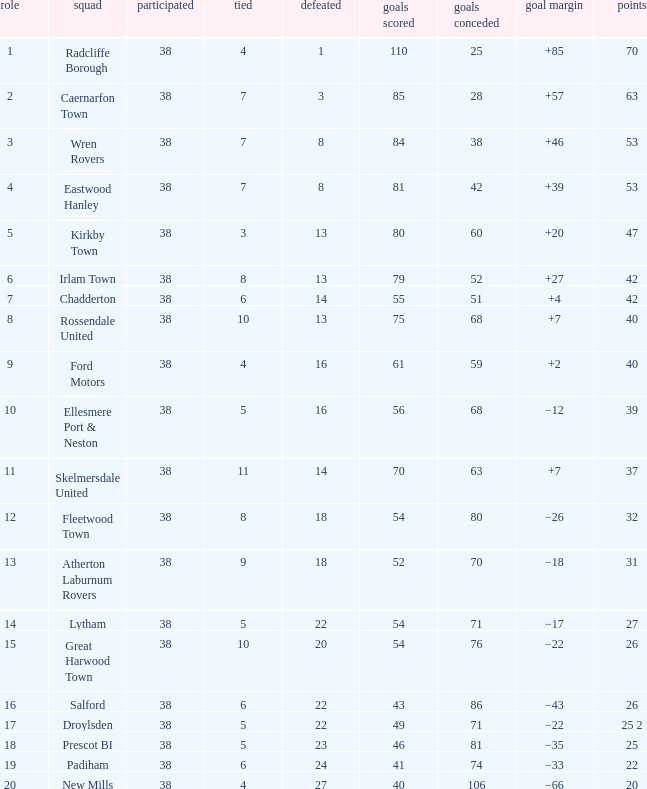Which Position has Goals For of 52, and Goals Against larger than 70? None. 